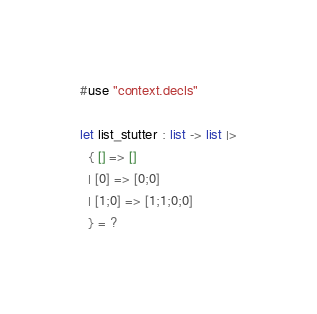<code> <loc_0><loc_0><loc_500><loc_500><_OCaml_>#use "context.decls"

let list_stutter : list -> list |>
  { [] => []
  | [0] => [0;0]
  | [1;0] => [1;1;0;0]
  } = ?
</code> 